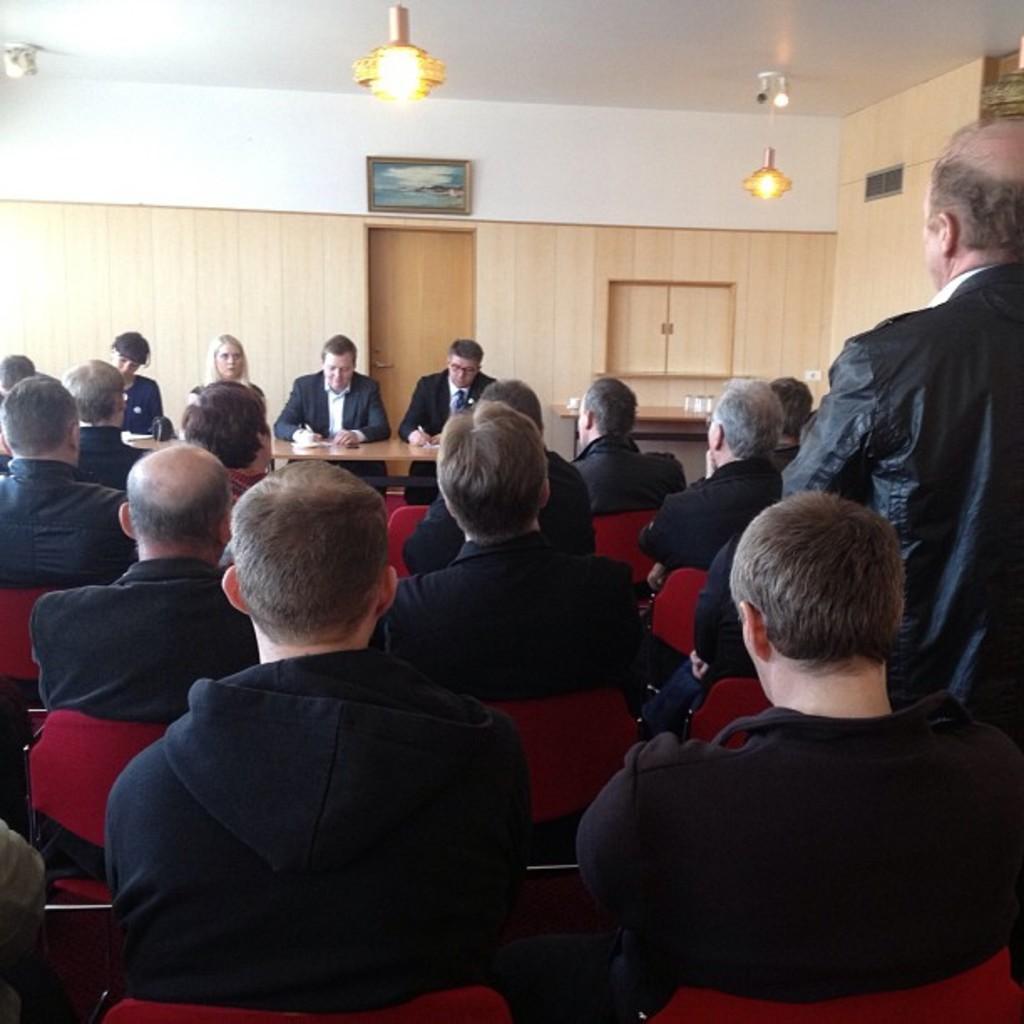Describe this image in one or two sentences. people are sitting on the red chairs wearing black dress. A man is standing at the right. there is a table, door and a photo frame at the back. There are lights on the top. 